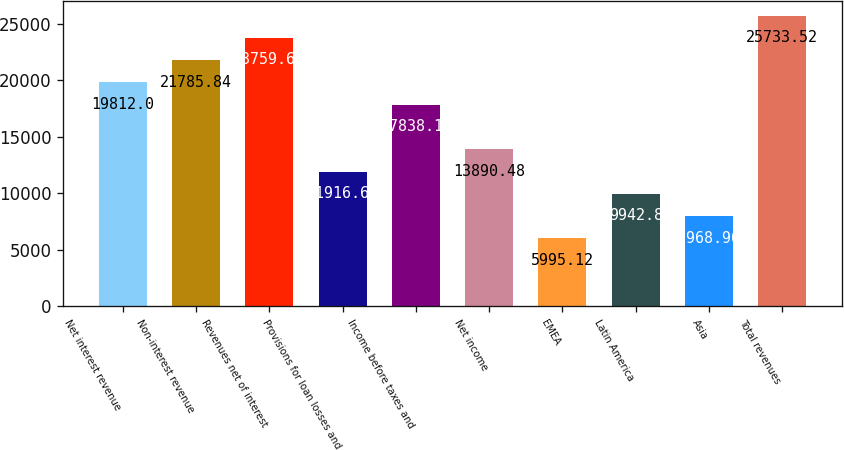Convert chart to OTSL. <chart><loc_0><loc_0><loc_500><loc_500><bar_chart><fcel>Net interest revenue<fcel>Non-interest revenue<fcel>Revenues net of interest<fcel>Provisions for loan losses and<fcel>Income before taxes and<fcel>Net income<fcel>EMEA<fcel>Latin America<fcel>Asia<fcel>Total revenues<nl><fcel>19812<fcel>21785.8<fcel>23759.7<fcel>11916.6<fcel>17838.2<fcel>13890.5<fcel>5995.12<fcel>9942.8<fcel>7968.96<fcel>25733.5<nl></chart> 